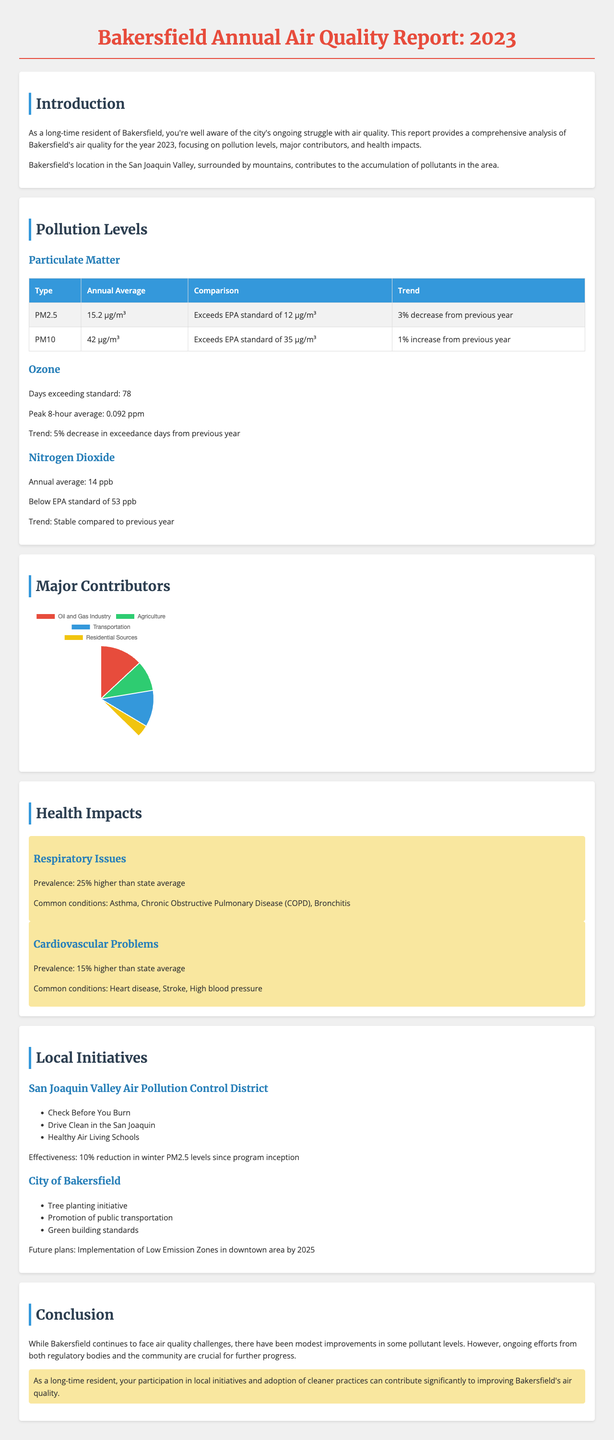What is the annual average of PM2.5? The annual average of PM2.5 is provided in the pollution levels section.
Answer: 15.2 μg/m³ What percentage of pollution is contributed by the oil and gas industry? The major contributors section lists the contribution percentages of different sectors.
Answer: 35% How many days exceeded the ozone standard? This information is listed under the ozone pollution levels.
Answer: 78 What is the prevalence of respiratory issues compared to the state average? The health impacts section describes the prevalence of respiratory issues against the state average.
Answer: 25% higher What is one of the local initiatives undertaken by the city of Bakersfield? The local initiatives section mentions various actions taken by the city.
Answer: Tree planting initiative What is the trend for PM10 pollution levels? The trend for PM10 is stated in the pollution levels section, referring to its change from the previous year.
Answer: 1% increase from previous year What is the peak 8-hour average for ozone? The peak 8-hour average of ozone is detailed in the pollution levels section.
Answer: 0.092 ppm What is the risk increase for children developing asthma? The health impacts section discusses vulnerable populations and the associated risks.
Answer: 30% higher risk of developing asthma 